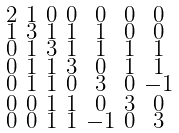<formula> <loc_0><loc_0><loc_500><loc_500>\begin{smallmatrix} 2 & 1 & 0 & 0 & 0 & 0 & 0 \\ 1 & 3 & 1 & 1 & 1 & 0 & 0 \\ 0 & 1 & 3 & 1 & 1 & 1 & 1 \\ 0 & 1 & 1 & 3 & 0 & 1 & 1 \\ 0 & 1 & 1 & 0 & 3 & 0 & - 1 \\ 0 & 0 & 1 & 1 & 0 & 3 & 0 \\ 0 & 0 & 1 & 1 & - 1 & 0 & 3 \end{smallmatrix}</formula> 